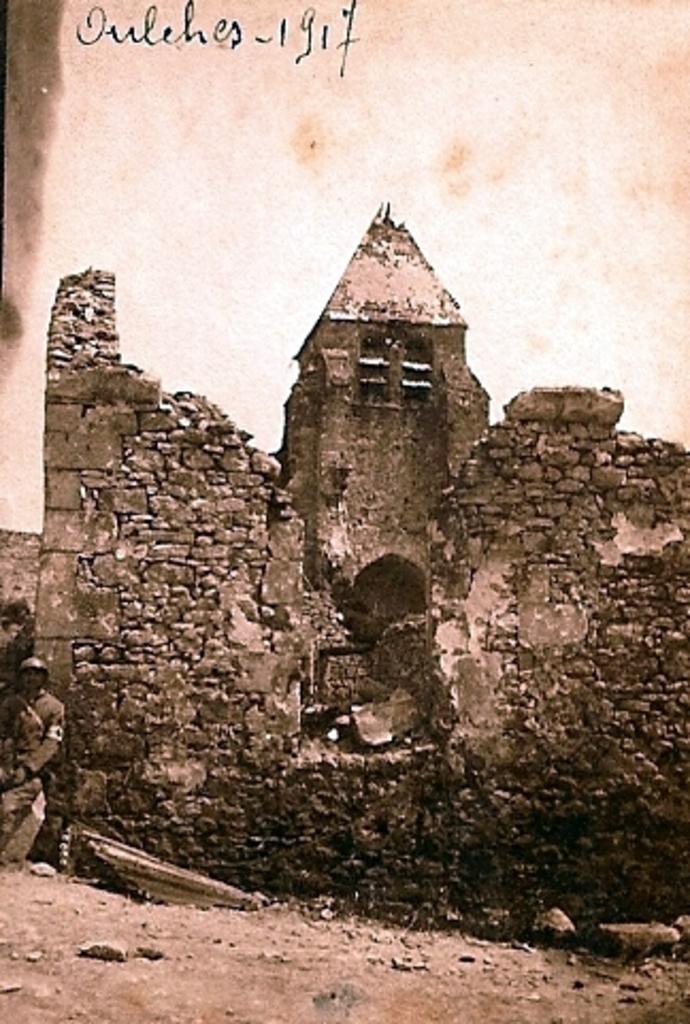Describe this image in one or two sentences. This image is an edited image. At the bottom of the image there is a ground. There are a few stones on the ground. In the middle of the image there is a collapsed building with a few walls. On the left side of the image there is a man standing on the ground and there is an object on the ground. At the top of the image there is the sky and there is a text in this image. 